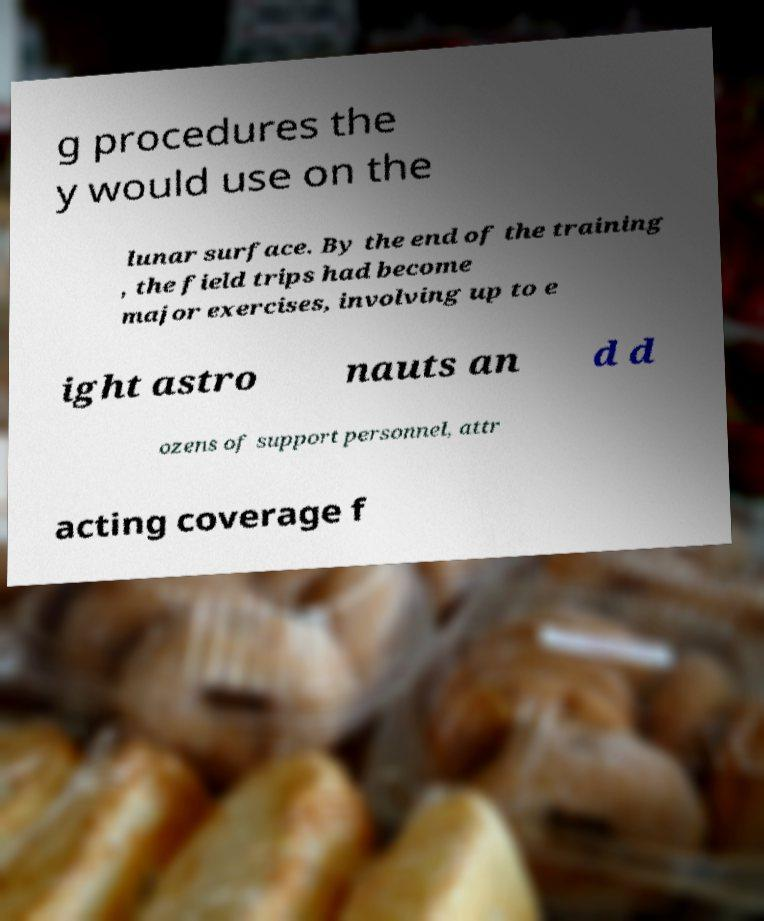Could you extract and type out the text from this image? g procedures the y would use on the lunar surface. By the end of the training , the field trips had become major exercises, involving up to e ight astro nauts an d d ozens of support personnel, attr acting coverage f 